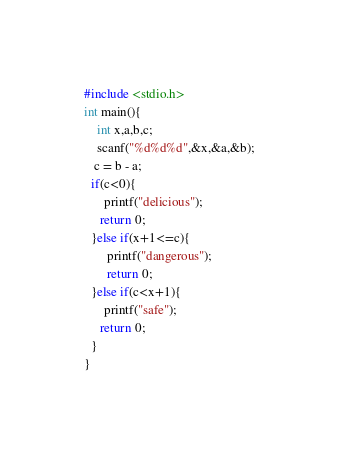<code> <loc_0><loc_0><loc_500><loc_500><_C_>#include <stdio.h>
int main(){
    int x,a,b,c;
    scanf("%d%d%d",&x,&a,&b);
   c = b - a;
  if(c<0){
      printf("delicious");
     return 0;
  }else if(x+1<=c){
       printf("dangerous");
       return 0;
  }else if(c<x+1){
      printf("safe");
     return 0;
  }
}</code> 